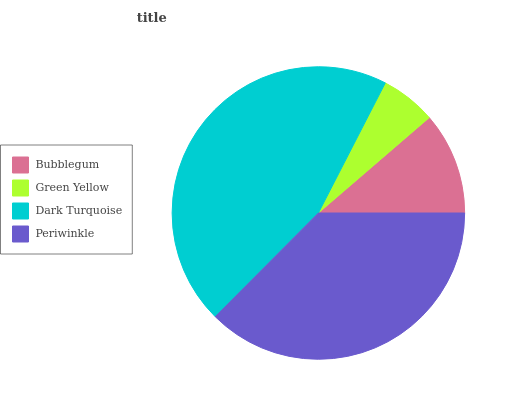Is Green Yellow the minimum?
Answer yes or no. Yes. Is Dark Turquoise the maximum?
Answer yes or no. Yes. Is Dark Turquoise the minimum?
Answer yes or no. No. Is Green Yellow the maximum?
Answer yes or no. No. Is Dark Turquoise greater than Green Yellow?
Answer yes or no. Yes. Is Green Yellow less than Dark Turquoise?
Answer yes or no. Yes. Is Green Yellow greater than Dark Turquoise?
Answer yes or no. No. Is Dark Turquoise less than Green Yellow?
Answer yes or no. No. Is Periwinkle the high median?
Answer yes or no. Yes. Is Bubblegum the low median?
Answer yes or no. Yes. Is Green Yellow the high median?
Answer yes or no. No. Is Dark Turquoise the low median?
Answer yes or no. No. 